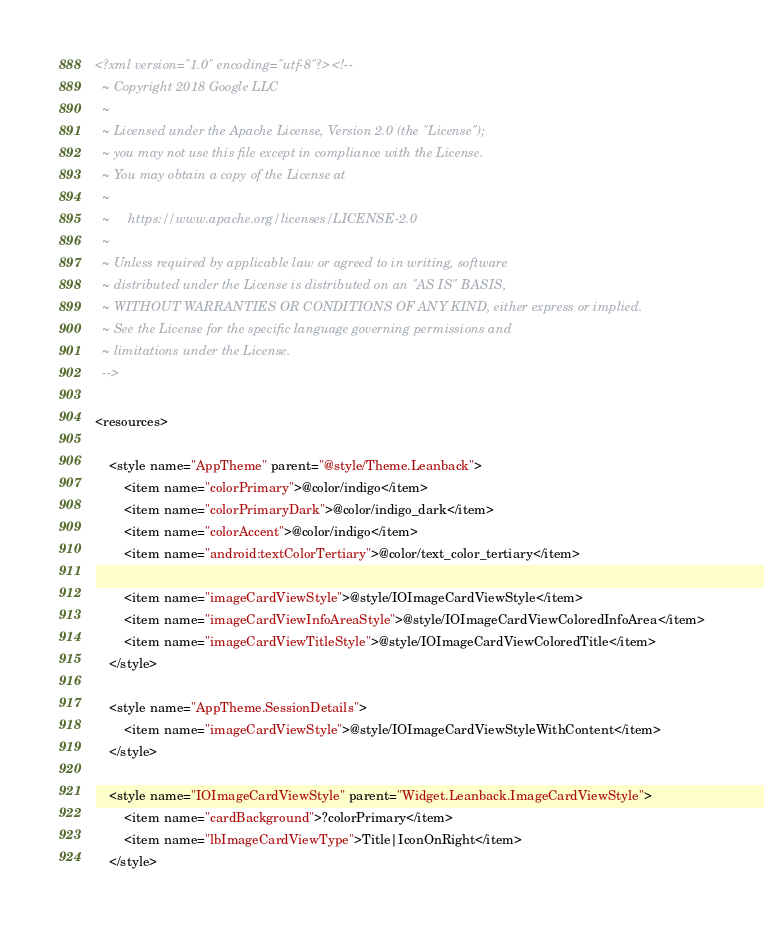<code> <loc_0><loc_0><loc_500><loc_500><_XML_><?xml version="1.0" encoding="utf-8"?><!--
  ~ Copyright 2018 Google LLC
  ~
  ~ Licensed under the Apache License, Version 2.0 (the "License");
  ~ you may not use this file except in compliance with the License.
  ~ You may obtain a copy of the License at
  ~
  ~     https://www.apache.org/licenses/LICENSE-2.0
  ~
  ~ Unless required by applicable law or agreed to in writing, software
  ~ distributed under the License is distributed on an "AS IS" BASIS,
  ~ WITHOUT WARRANTIES OR CONDITIONS OF ANY KIND, either express or implied.
  ~ See the License for the specific language governing permissions and
  ~ limitations under the License.
  -->

<resources>

    <style name="AppTheme" parent="@style/Theme.Leanback">
        <item name="colorPrimary">@color/indigo</item>
        <item name="colorPrimaryDark">@color/indigo_dark</item>
        <item name="colorAccent">@color/indigo</item>
        <item name="android:textColorTertiary">@color/text_color_tertiary</item>

        <item name="imageCardViewStyle">@style/IOImageCardViewStyle</item>
        <item name="imageCardViewInfoAreaStyle">@style/IOImageCardViewColoredInfoArea</item>
        <item name="imageCardViewTitleStyle">@style/IOImageCardViewColoredTitle</item>
    </style>

    <style name="AppTheme.SessionDetails">
        <item name="imageCardViewStyle">@style/IOImageCardViewStyleWithContent</item>
    </style>

    <style name="IOImageCardViewStyle" parent="Widget.Leanback.ImageCardViewStyle">
        <item name="cardBackground">?colorPrimary</item>
        <item name="lbImageCardViewType">Title|IconOnRight</item>
    </style>
</code> 